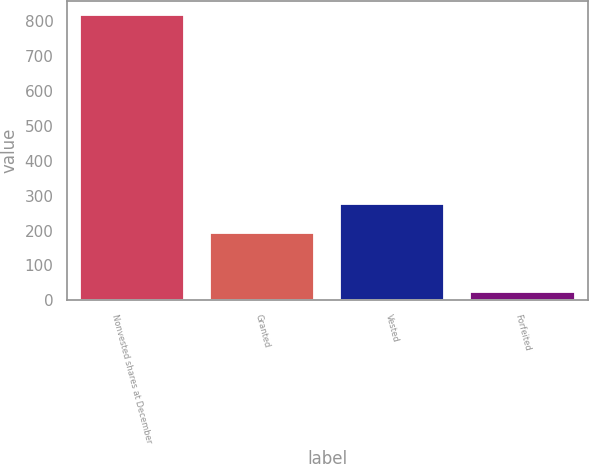Convert chart. <chart><loc_0><loc_0><loc_500><loc_500><bar_chart><fcel>Nonvested shares at December<fcel>Granted<fcel>Vested<fcel>Forfeited<nl><fcel>817<fcel>192<fcel>275.7<fcel>24<nl></chart> 